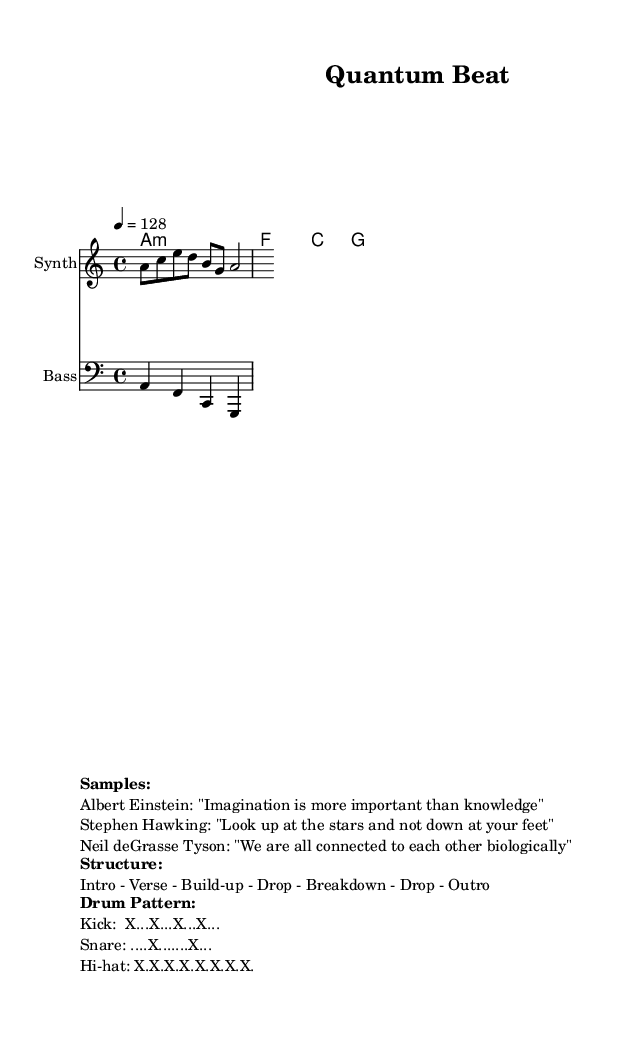What is the key signature of this music? The key signature is A minor, which has no sharps or flats.
Answer: A minor What is the time signature of this music? The time signature is 4/4, meaning there are four beats in each measure.
Answer: 4/4 What is the tempo marking for this piece? The tempo marking indicates that the piece should be played at 128 beats per minute, as shown by "4 = 128".
Answer: 128 How many different quotes from famous scientists are sampled in this piece? The markup lists three quotes from scientists: Albert Einstein, Stephen Hawking, and Neil deGrasse Tyson, suggesting there are three samples.
Answer: 3 What is the overall structure of this energetic house track? The structure is made up of an Intro, Verse, Build-up, Drop, Breakdown, another Drop, and an Outro, as outlined in the markup.
Answer: Intro - Verse - Build-up - Drop - Breakdown - Drop - Outro What instruments are indicated in the score? The score includes a Synth for the melody and a Bass for the bass lines, clearly specified in the staff settings.
Answer: Synth, Bass What type of drum pattern is represented in this piece? The drum pattern is typical for house music, featuring a kick, snare, and hi-hat arrangement, as detailed in the markup.
Answer: Kick, Snare, Hi-hat 